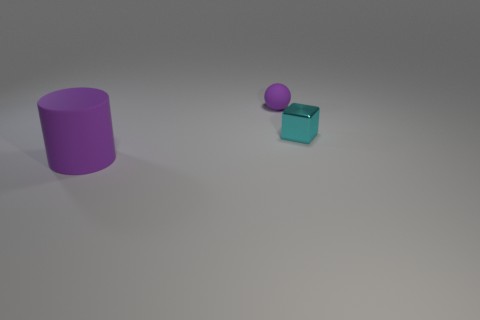The matte object behind the purple cylinder is what color?
Give a very brief answer. Purple. What is the shape of the large purple thing?
Your answer should be very brief. Cylinder. Are there any small cyan shiny objects that are behind the purple object behind the thing that is in front of the cyan metal thing?
Provide a succinct answer. No. There is a thing that is left of the purple thing behind the thing in front of the tiny cyan thing; what is its color?
Provide a short and direct response. Purple. What is the size of the rubber thing to the right of the purple thing in front of the tiny cyan object?
Keep it short and to the point. Small. There is a cylinder in front of the metallic cube; what is its material?
Give a very brief answer. Rubber. What is the size of the purple cylinder that is the same material as the tiny purple thing?
Offer a terse response. Large. How many cyan things are the same shape as the large purple thing?
Give a very brief answer. 0. Do the small cyan thing and the purple thing behind the tiny cyan cube have the same shape?
Give a very brief answer. No. What is the shape of the tiny thing that is the same color as the large object?
Provide a succinct answer. Sphere. 